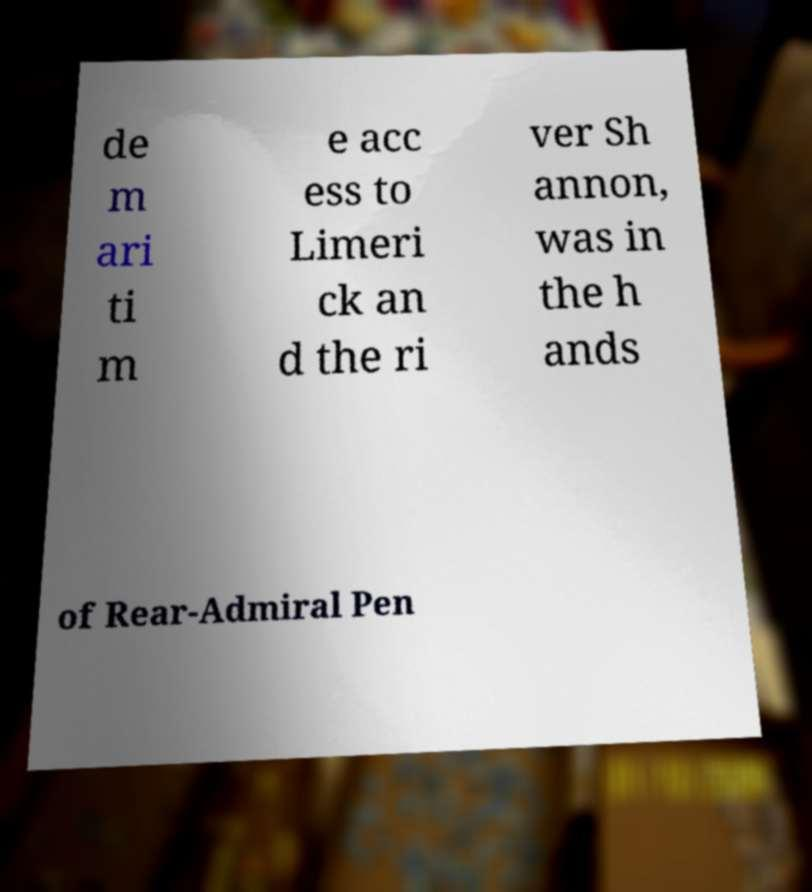Please identify and transcribe the text found in this image. de m ari ti m e acc ess to Limeri ck an d the ri ver Sh annon, was in the h ands of Rear-Admiral Pen 